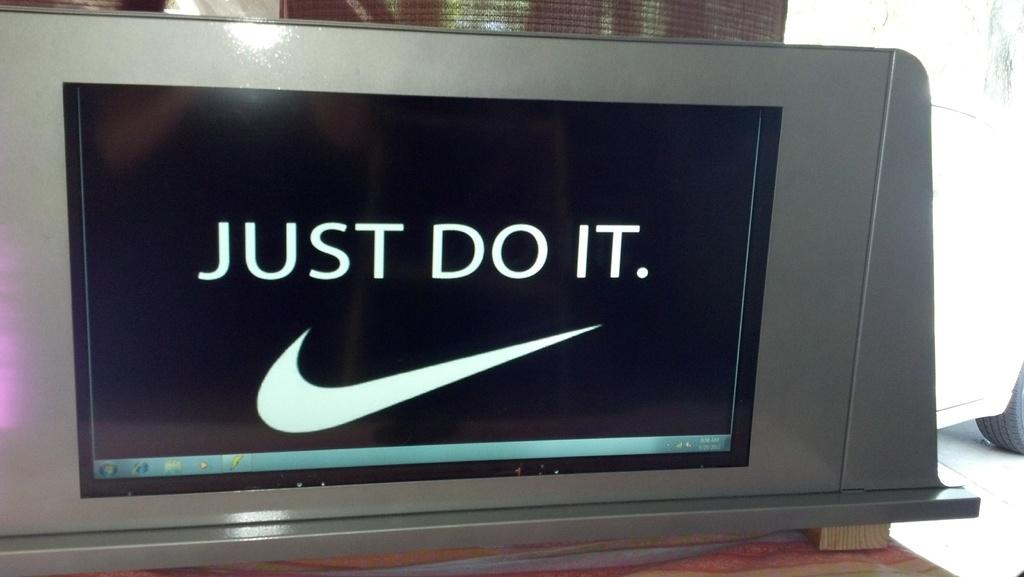<image>
Summarize the visual content of the image. An advertising sign with the Nike swoosh symbol and the words Just Do It. 